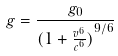<formula> <loc_0><loc_0><loc_500><loc_500>g = \frac { g _ { 0 } } { ( { 1 + \frac { v ^ { 6 } } { c ^ { 6 } } ) } ^ { 9 / 6 } }</formula> 